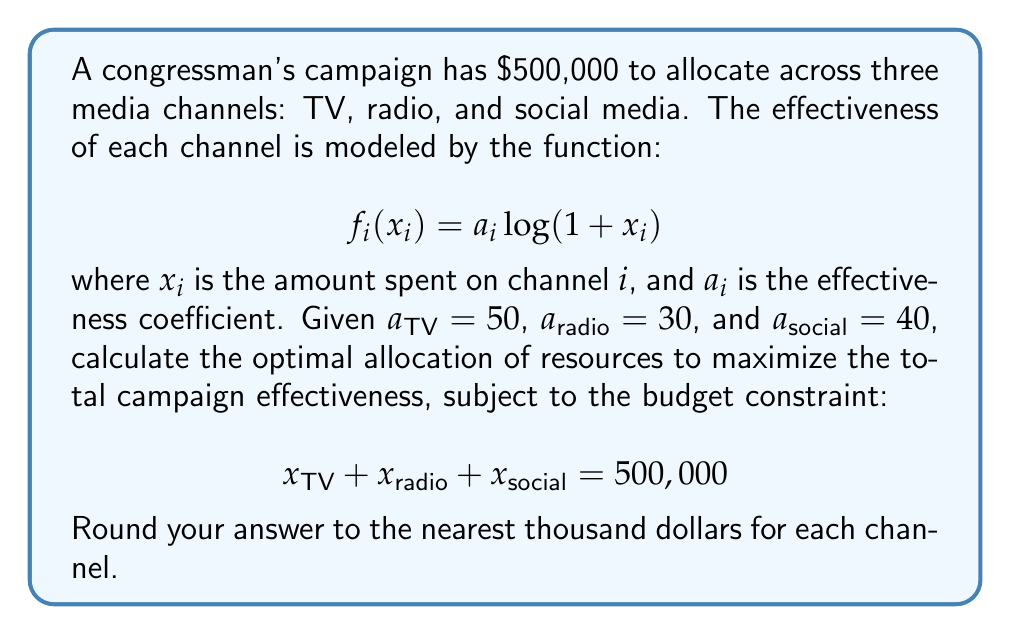Help me with this question. To solve this optimization problem, we'll use the method of Lagrange multipliers:

1) Define the objective function:
   $$F = 50\log(1+x_{TV}) + 30\log(1+x_{radio}) + 40\log(1+x_{social})$$

2) Set up the Lagrangian:
   $$L = F + \lambda(500000 - x_{TV} - x_{radio} - x_{social})$$

3) Take partial derivatives and set them equal to zero:
   $$\frac{\partial L}{\partial x_{TV}} = \frac{50}{1+x_{TV}} - \lambda = 0$$
   $$\frac{\partial L}{\partial x_{radio}} = \frac{30}{1+x_{radio}} - \lambda = 0$$
   $$\frac{\partial L}{\partial x_{social}} = \frac{40}{1+x_{social}} - \lambda = 0$$
   $$\frac{\partial L}{\partial \lambda} = 500000 - x_{TV} - x_{radio} - x_{social} = 0$$

4) From these equations, we can derive:
   $$x_{TV} + 1 = \frac{50}{\lambda}$$
   $$x_{radio} + 1 = \frac{30}{\lambda}$$
   $$x_{social} + 1 = \frac{40}{\lambda}$$

5) Substituting into the budget constraint:
   $$500000 = (\frac{50}{\lambda} - 1) + (\frac{30}{\lambda} - 1) + (\frac{40}{\lambda} - 1)$$

6) Simplifying:
   $$500003 = \frac{120}{\lambda}$$
   $$\lambda = \frac{120}{500003} \approx 0.00024$$

7) Substituting back:
   $$x_{TV} = \frac{50}{0.00024} - 1 \approx 208332$$
   $$x_{radio} = \frac{30}{0.00024} - 1 \approx 124999$$
   $$x_{social} = \frac{40}{0.00024} - 1 \approx 166666$$

8) Rounding to the nearest thousand:
   $$x_{TV} \approx 208,000$$
   $$x_{radio} \approx 125,000$$
   $$x_{social} \approx 167,000$$
Answer: TV: $208,000, Radio: $125,000, Social Media: $167,000 